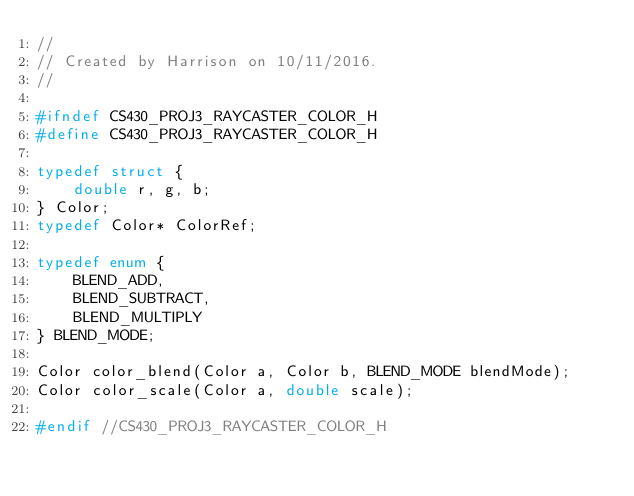<code> <loc_0><loc_0><loc_500><loc_500><_C_>//
// Created by Harrison on 10/11/2016.
//

#ifndef CS430_PROJ3_RAYCASTER_COLOR_H
#define CS430_PROJ3_RAYCASTER_COLOR_H

typedef struct {
    double r, g, b;
} Color;
typedef Color* ColorRef;

typedef enum {
    BLEND_ADD,
    BLEND_SUBTRACT,
    BLEND_MULTIPLY
} BLEND_MODE;

Color color_blend(Color a, Color b, BLEND_MODE blendMode);
Color color_scale(Color a, double scale);

#endif //CS430_PROJ3_RAYCASTER_COLOR_H
</code> 